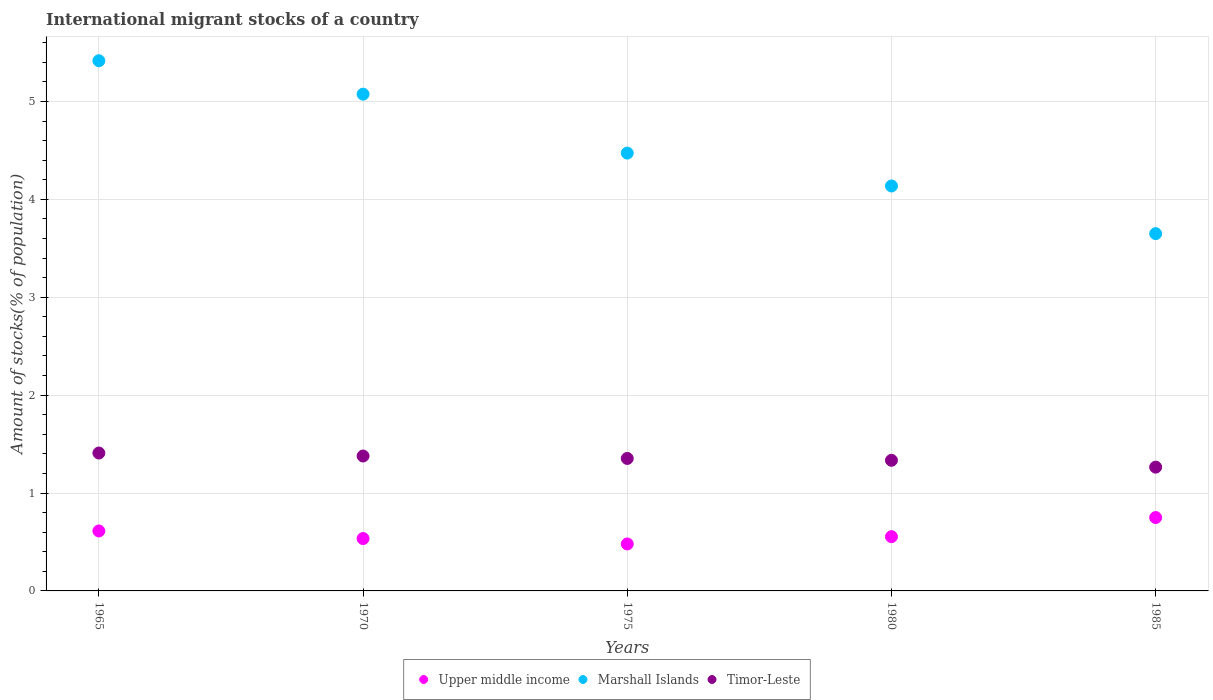What is the amount of stocks in in Upper middle income in 1985?
Your answer should be very brief. 0.75. Across all years, what is the maximum amount of stocks in in Timor-Leste?
Ensure brevity in your answer.  1.41. Across all years, what is the minimum amount of stocks in in Upper middle income?
Provide a succinct answer. 0.48. In which year was the amount of stocks in in Marshall Islands maximum?
Make the answer very short. 1965. In which year was the amount of stocks in in Upper middle income minimum?
Give a very brief answer. 1975. What is the total amount of stocks in in Upper middle income in the graph?
Provide a short and direct response. 2.93. What is the difference between the amount of stocks in in Upper middle income in 1965 and that in 1985?
Make the answer very short. -0.14. What is the difference between the amount of stocks in in Marshall Islands in 1985 and the amount of stocks in in Timor-Leste in 1975?
Offer a terse response. 2.3. What is the average amount of stocks in in Timor-Leste per year?
Ensure brevity in your answer.  1.35. In the year 1970, what is the difference between the amount of stocks in in Marshall Islands and amount of stocks in in Upper middle income?
Keep it short and to the point. 4.54. In how many years, is the amount of stocks in in Timor-Leste greater than 4 %?
Offer a terse response. 0. What is the ratio of the amount of stocks in in Timor-Leste in 1965 to that in 1980?
Your response must be concise. 1.06. Is the amount of stocks in in Marshall Islands in 1965 less than that in 1975?
Give a very brief answer. No. Is the difference between the amount of stocks in in Marshall Islands in 1970 and 1975 greater than the difference between the amount of stocks in in Upper middle income in 1970 and 1975?
Provide a succinct answer. Yes. What is the difference between the highest and the second highest amount of stocks in in Marshall Islands?
Offer a very short reply. 0.34. What is the difference between the highest and the lowest amount of stocks in in Upper middle income?
Your answer should be very brief. 0.27. Is the amount of stocks in in Upper middle income strictly greater than the amount of stocks in in Marshall Islands over the years?
Offer a very short reply. No. Is the amount of stocks in in Marshall Islands strictly less than the amount of stocks in in Timor-Leste over the years?
Offer a very short reply. No. How many years are there in the graph?
Offer a terse response. 5. Does the graph contain any zero values?
Give a very brief answer. No. Where does the legend appear in the graph?
Provide a succinct answer. Bottom center. How many legend labels are there?
Keep it short and to the point. 3. How are the legend labels stacked?
Make the answer very short. Horizontal. What is the title of the graph?
Keep it short and to the point. International migrant stocks of a country. What is the label or title of the Y-axis?
Make the answer very short. Amount of stocks(% of population). What is the Amount of stocks(% of population) in Upper middle income in 1965?
Ensure brevity in your answer.  0.61. What is the Amount of stocks(% of population) in Marshall Islands in 1965?
Your answer should be very brief. 5.42. What is the Amount of stocks(% of population) of Timor-Leste in 1965?
Offer a terse response. 1.41. What is the Amount of stocks(% of population) in Upper middle income in 1970?
Keep it short and to the point. 0.54. What is the Amount of stocks(% of population) of Marshall Islands in 1970?
Your answer should be compact. 5.07. What is the Amount of stocks(% of population) of Timor-Leste in 1970?
Ensure brevity in your answer.  1.38. What is the Amount of stocks(% of population) of Upper middle income in 1975?
Give a very brief answer. 0.48. What is the Amount of stocks(% of population) of Marshall Islands in 1975?
Ensure brevity in your answer.  4.47. What is the Amount of stocks(% of population) of Timor-Leste in 1975?
Provide a short and direct response. 1.35. What is the Amount of stocks(% of population) in Upper middle income in 1980?
Make the answer very short. 0.55. What is the Amount of stocks(% of population) of Marshall Islands in 1980?
Provide a short and direct response. 4.14. What is the Amount of stocks(% of population) of Timor-Leste in 1980?
Give a very brief answer. 1.33. What is the Amount of stocks(% of population) of Upper middle income in 1985?
Keep it short and to the point. 0.75. What is the Amount of stocks(% of population) of Marshall Islands in 1985?
Keep it short and to the point. 3.65. What is the Amount of stocks(% of population) of Timor-Leste in 1985?
Keep it short and to the point. 1.26. Across all years, what is the maximum Amount of stocks(% of population) in Upper middle income?
Provide a short and direct response. 0.75. Across all years, what is the maximum Amount of stocks(% of population) in Marshall Islands?
Provide a short and direct response. 5.42. Across all years, what is the maximum Amount of stocks(% of population) of Timor-Leste?
Your answer should be compact. 1.41. Across all years, what is the minimum Amount of stocks(% of population) in Upper middle income?
Offer a very short reply. 0.48. Across all years, what is the minimum Amount of stocks(% of population) in Marshall Islands?
Your answer should be very brief. 3.65. Across all years, what is the minimum Amount of stocks(% of population) of Timor-Leste?
Provide a succinct answer. 1.26. What is the total Amount of stocks(% of population) of Upper middle income in the graph?
Offer a terse response. 2.93. What is the total Amount of stocks(% of population) of Marshall Islands in the graph?
Ensure brevity in your answer.  22.75. What is the total Amount of stocks(% of population) in Timor-Leste in the graph?
Your answer should be compact. 6.74. What is the difference between the Amount of stocks(% of population) in Upper middle income in 1965 and that in 1970?
Give a very brief answer. 0.08. What is the difference between the Amount of stocks(% of population) in Marshall Islands in 1965 and that in 1970?
Ensure brevity in your answer.  0.34. What is the difference between the Amount of stocks(% of population) in Timor-Leste in 1965 and that in 1970?
Make the answer very short. 0.03. What is the difference between the Amount of stocks(% of population) of Upper middle income in 1965 and that in 1975?
Your answer should be compact. 0.13. What is the difference between the Amount of stocks(% of population) in Marshall Islands in 1965 and that in 1975?
Provide a succinct answer. 0.94. What is the difference between the Amount of stocks(% of population) in Timor-Leste in 1965 and that in 1975?
Provide a succinct answer. 0.06. What is the difference between the Amount of stocks(% of population) in Upper middle income in 1965 and that in 1980?
Your response must be concise. 0.06. What is the difference between the Amount of stocks(% of population) of Marshall Islands in 1965 and that in 1980?
Your answer should be compact. 1.28. What is the difference between the Amount of stocks(% of population) in Timor-Leste in 1965 and that in 1980?
Provide a short and direct response. 0.07. What is the difference between the Amount of stocks(% of population) of Upper middle income in 1965 and that in 1985?
Ensure brevity in your answer.  -0.14. What is the difference between the Amount of stocks(% of population) of Marshall Islands in 1965 and that in 1985?
Make the answer very short. 1.77. What is the difference between the Amount of stocks(% of population) in Timor-Leste in 1965 and that in 1985?
Ensure brevity in your answer.  0.14. What is the difference between the Amount of stocks(% of population) in Upper middle income in 1970 and that in 1975?
Give a very brief answer. 0.06. What is the difference between the Amount of stocks(% of population) of Marshall Islands in 1970 and that in 1975?
Your response must be concise. 0.6. What is the difference between the Amount of stocks(% of population) in Timor-Leste in 1970 and that in 1975?
Offer a very short reply. 0.02. What is the difference between the Amount of stocks(% of population) in Upper middle income in 1970 and that in 1980?
Provide a succinct answer. -0.02. What is the difference between the Amount of stocks(% of population) in Marshall Islands in 1970 and that in 1980?
Keep it short and to the point. 0.94. What is the difference between the Amount of stocks(% of population) of Timor-Leste in 1970 and that in 1980?
Your response must be concise. 0.04. What is the difference between the Amount of stocks(% of population) in Upper middle income in 1970 and that in 1985?
Make the answer very short. -0.21. What is the difference between the Amount of stocks(% of population) in Marshall Islands in 1970 and that in 1985?
Your answer should be very brief. 1.42. What is the difference between the Amount of stocks(% of population) in Timor-Leste in 1970 and that in 1985?
Provide a short and direct response. 0.11. What is the difference between the Amount of stocks(% of population) in Upper middle income in 1975 and that in 1980?
Give a very brief answer. -0.07. What is the difference between the Amount of stocks(% of population) of Marshall Islands in 1975 and that in 1980?
Make the answer very short. 0.34. What is the difference between the Amount of stocks(% of population) in Timor-Leste in 1975 and that in 1980?
Your answer should be compact. 0.02. What is the difference between the Amount of stocks(% of population) in Upper middle income in 1975 and that in 1985?
Provide a succinct answer. -0.27. What is the difference between the Amount of stocks(% of population) of Marshall Islands in 1975 and that in 1985?
Your answer should be compact. 0.82. What is the difference between the Amount of stocks(% of population) in Timor-Leste in 1975 and that in 1985?
Keep it short and to the point. 0.09. What is the difference between the Amount of stocks(% of population) of Upper middle income in 1980 and that in 1985?
Your response must be concise. -0.2. What is the difference between the Amount of stocks(% of population) in Marshall Islands in 1980 and that in 1985?
Give a very brief answer. 0.49. What is the difference between the Amount of stocks(% of population) of Timor-Leste in 1980 and that in 1985?
Ensure brevity in your answer.  0.07. What is the difference between the Amount of stocks(% of population) in Upper middle income in 1965 and the Amount of stocks(% of population) in Marshall Islands in 1970?
Provide a short and direct response. -4.46. What is the difference between the Amount of stocks(% of population) in Upper middle income in 1965 and the Amount of stocks(% of population) in Timor-Leste in 1970?
Make the answer very short. -0.77. What is the difference between the Amount of stocks(% of population) of Marshall Islands in 1965 and the Amount of stocks(% of population) of Timor-Leste in 1970?
Offer a terse response. 4.04. What is the difference between the Amount of stocks(% of population) in Upper middle income in 1965 and the Amount of stocks(% of population) in Marshall Islands in 1975?
Make the answer very short. -3.86. What is the difference between the Amount of stocks(% of population) in Upper middle income in 1965 and the Amount of stocks(% of population) in Timor-Leste in 1975?
Offer a terse response. -0.74. What is the difference between the Amount of stocks(% of population) in Marshall Islands in 1965 and the Amount of stocks(% of population) in Timor-Leste in 1975?
Offer a terse response. 4.06. What is the difference between the Amount of stocks(% of population) of Upper middle income in 1965 and the Amount of stocks(% of population) of Marshall Islands in 1980?
Ensure brevity in your answer.  -3.52. What is the difference between the Amount of stocks(% of population) in Upper middle income in 1965 and the Amount of stocks(% of population) in Timor-Leste in 1980?
Provide a succinct answer. -0.72. What is the difference between the Amount of stocks(% of population) of Marshall Islands in 1965 and the Amount of stocks(% of population) of Timor-Leste in 1980?
Your answer should be very brief. 4.08. What is the difference between the Amount of stocks(% of population) of Upper middle income in 1965 and the Amount of stocks(% of population) of Marshall Islands in 1985?
Your answer should be very brief. -3.04. What is the difference between the Amount of stocks(% of population) of Upper middle income in 1965 and the Amount of stocks(% of population) of Timor-Leste in 1985?
Provide a short and direct response. -0.65. What is the difference between the Amount of stocks(% of population) in Marshall Islands in 1965 and the Amount of stocks(% of population) in Timor-Leste in 1985?
Offer a terse response. 4.15. What is the difference between the Amount of stocks(% of population) of Upper middle income in 1970 and the Amount of stocks(% of population) of Marshall Islands in 1975?
Make the answer very short. -3.94. What is the difference between the Amount of stocks(% of population) in Upper middle income in 1970 and the Amount of stocks(% of population) in Timor-Leste in 1975?
Offer a terse response. -0.82. What is the difference between the Amount of stocks(% of population) of Marshall Islands in 1970 and the Amount of stocks(% of population) of Timor-Leste in 1975?
Offer a very short reply. 3.72. What is the difference between the Amount of stocks(% of population) of Upper middle income in 1970 and the Amount of stocks(% of population) of Marshall Islands in 1980?
Provide a succinct answer. -3.6. What is the difference between the Amount of stocks(% of population) of Upper middle income in 1970 and the Amount of stocks(% of population) of Timor-Leste in 1980?
Your answer should be compact. -0.8. What is the difference between the Amount of stocks(% of population) in Marshall Islands in 1970 and the Amount of stocks(% of population) in Timor-Leste in 1980?
Keep it short and to the point. 3.74. What is the difference between the Amount of stocks(% of population) in Upper middle income in 1970 and the Amount of stocks(% of population) in Marshall Islands in 1985?
Provide a short and direct response. -3.11. What is the difference between the Amount of stocks(% of population) in Upper middle income in 1970 and the Amount of stocks(% of population) in Timor-Leste in 1985?
Your answer should be compact. -0.73. What is the difference between the Amount of stocks(% of population) of Marshall Islands in 1970 and the Amount of stocks(% of population) of Timor-Leste in 1985?
Your answer should be compact. 3.81. What is the difference between the Amount of stocks(% of population) in Upper middle income in 1975 and the Amount of stocks(% of population) in Marshall Islands in 1980?
Provide a short and direct response. -3.66. What is the difference between the Amount of stocks(% of population) in Upper middle income in 1975 and the Amount of stocks(% of population) in Timor-Leste in 1980?
Make the answer very short. -0.85. What is the difference between the Amount of stocks(% of population) in Marshall Islands in 1975 and the Amount of stocks(% of population) in Timor-Leste in 1980?
Offer a terse response. 3.14. What is the difference between the Amount of stocks(% of population) of Upper middle income in 1975 and the Amount of stocks(% of population) of Marshall Islands in 1985?
Offer a terse response. -3.17. What is the difference between the Amount of stocks(% of population) of Upper middle income in 1975 and the Amount of stocks(% of population) of Timor-Leste in 1985?
Ensure brevity in your answer.  -0.78. What is the difference between the Amount of stocks(% of population) in Marshall Islands in 1975 and the Amount of stocks(% of population) in Timor-Leste in 1985?
Give a very brief answer. 3.21. What is the difference between the Amount of stocks(% of population) in Upper middle income in 1980 and the Amount of stocks(% of population) in Marshall Islands in 1985?
Give a very brief answer. -3.1. What is the difference between the Amount of stocks(% of population) in Upper middle income in 1980 and the Amount of stocks(% of population) in Timor-Leste in 1985?
Keep it short and to the point. -0.71. What is the difference between the Amount of stocks(% of population) in Marshall Islands in 1980 and the Amount of stocks(% of population) in Timor-Leste in 1985?
Give a very brief answer. 2.87. What is the average Amount of stocks(% of population) in Upper middle income per year?
Give a very brief answer. 0.59. What is the average Amount of stocks(% of population) in Marshall Islands per year?
Provide a short and direct response. 4.55. What is the average Amount of stocks(% of population) of Timor-Leste per year?
Your response must be concise. 1.35. In the year 1965, what is the difference between the Amount of stocks(% of population) of Upper middle income and Amount of stocks(% of population) of Marshall Islands?
Keep it short and to the point. -4.8. In the year 1965, what is the difference between the Amount of stocks(% of population) in Upper middle income and Amount of stocks(% of population) in Timor-Leste?
Give a very brief answer. -0.8. In the year 1965, what is the difference between the Amount of stocks(% of population) of Marshall Islands and Amount of stocks(% of population) of Timor-Leste?
Offer a very short reply. 4.01. In the year 1970, what is the difference between the Amount of stocks(% of population) of Upper middle income and Amount of stocks(% of population) of Marshall Islands?
Your response must be concise. -4.54. In the year 1970, what is the difference between the Amount of stocks(% of population) of Upper middle income and Amount of stocks(% of population) of Timor-Leste?
Your response must be concise. -0.84. In the year 1970, what is the difference between the Amount of stocks(% of population) of Marshall Islands and Amount of stocks(% of population) of Timor-Leste?
Give a very brief answer. 3.7. In the year 1975, what is the difference between the Amount of stocks(% of population) of Upper middle income and Amount of stocks(% of population) of Marshall Islands?
Your response must be concise. -3.99. In the year 1975, what is the difference between the Amount of stocks(% of population) in Upper middle income and Amount of stocks(% of population) in Timor-Leste?
Offer a terse response. -0.87. In the year 1975, what is the difference between the Amount of stocks(% of population) of Marshall Islands and Amount of stocks(% of population) of Timor-Leste?
Your answer should be compact. 3.12. In the year 1980, what is the difference between the Amount of stocks(% of population) of Upper middle income and Amount of stocks(% of population) of Marshall Islands?
Offer a terse response. -3.58. In the year 1980, what is the difference between the Amount of stocks(% of population) of Upper middle income and Amount of stocks(% of population) of Timor-Leste?
Ensure brevity in your answer.  -0.78. In the year 1980, what is the difference between the Amount of stocks(% of population) of Marshall Islands and Amount of stocks(% of population) of Timor-Leste?
Give a very brief answer. 2.8. In the year 1985, what is the difference between the Amount of stocks(% of population) in Upper middle income and Amount of stocks(% of population) in Marshall Islands?
Give a very brief answer. -2.9. In the year 1985, what is the difference between the Amount of stocks(% of population) of Upper middle income and Amount of stocks(% of population) of Timor-Leste?
Provide a succinct answer. -0.51. In the year 1985, what is the difference between the Amount of stocks(% of population) of Marshall Islands and Amount of stocks(% of population) of Timor-Leste?
Keep it short and to the point. 2.39. What is the ratio of the Amount of stocks(% of population) of Upper middle income in 1965 to that in 1970?
Provide a succinct answer. 1.14. What is the ratio of the Amount of stocks(% of population) in Marshall Islands in 1965 to that in 1970?
Provide a succinct answer. 1.07. What is the ratio of the Amount of stocks(% of population) in Timor-Leste in 1965 to that in 1970?
Keep it short and to the point. 1.02. What is the ratio of the Amount of stocks(% of population) in Upper middle income in 1965 to that in 1975?
Make the answer very short. 1.28. What is the ratio of the Amount of stocks(% of population) in Marshall Islands in 1965 to that in 1975?
Your answer should be very brief. 1.21. What is the ratio of the Amount of stocks(% of population) of Timor-Leste in 1965 to that in 1975?
Offer a terse response. 1.04. What is the ratio of the Amount of stocks(% of population) in Upper middle income in 1965 to that in 1980?
Keep it short and to the point. 1.11. What is the ratio of the Amount of stocks(% of population) in Marshall Islands in 1965 to that in 1980?
Give a very brief answer. 1.31. What is the ratio of the Amount of stocks(% of population) of Timor-Leste in 1965 to that in 1980?
Give a very brief answer. 1.06. What is the ratio of the Amount of stocks(% of population) of Upper middle income in 1965 to that in 1985?
Provide a succinct answer. 0.82. What is the ratio of the Amount of stocks(% of population) in Marshall Islands in 1965 to that in 1985?
Provide a succinct answer. 1.48. What is the ratio of the Amount of stocks(% of population) of Timor-Leste in 1965 to that in 1985?
Ensure brevity in your answer.  1.11. What is the ratio of the Amount of stocks(% of population) in Upper middle income in 1970 to that in 1975?
Give a very brief answer. 1.12. What is the ratio of the Amount of stocks(% of population) in Marshall Islands in 1970 to that in 1975?
Make the answer very short. 1.13. What is the ratio of the Amount of stocks(% of population) in Timor-Leste in 1970 to that in 1975?
Make the answer very short. 1.02. What is the ratio of the Amount of stocks(% of population) of Upper middle income in 1970 to that in 1980?
Your response must be concise. 0.97. What is the ratio of the Amount of stocks(% of population) in Marshall Islands in 1970 to that in 1980?
Offer a terse response. 1.23. What is the ratio of the Amount of stocks(% of population) of Timor-Leste in 1970 to that in 1980?
Your answer should be very brief. 1.03. What is the ratio of the Amount of stocks(% of population) of Upper middle income in 1970 to that in 1985?
Offer a very short reply. 0.71. What is the ratio of the Amount of stocks(% of population) in Marshall Islands in 1970 to that in 1985?
Offer a terse response. 1.39. What is the ratio of the Amount of stocks(% of population) in Timor-Leste in 1970 to that in 1985?
Your answer should be compact. 1.09. What is the ratio of the Amount of stocks(% of population) in Upper middle income in 1975 to that in 1980?
Provide a short and direct response. 0.87. What is the ratio of the Amount of stocks(% of population) of Marshall Islands in 1975 to that in 1980?
Your answer should be compact. 1.08. What is the ratio of the Amount of stocks(% of population) in Timor-Leste in 1975 to that in 1980?
Your answer should be very brief. 1.01. What is the ratio of the Amount of stocks(% of population) in Upper middle income in 1975 to that in 1985?
Your answer should be compact. 0.64. What is the ratio of the Amount of stocks(% of population) of Marshall Islands in 1975 to that in 1985?
Your answer should be compact. 1.23. What is the ratio of the Amount of stocks(% of population) of Timor-Leste in 1975 to that in 1985?
Make the answer very short. 1.07. What is the ratio of the Amount of stocks(% of population) in Upper middle income in 1980 to that in 1985?
Make the answer very short. 0.74. What is the ratio of the Amount of stocks(% of population) in Marshall Islands in 1980 to that in 1985?
Your answer should be compact. 1.13. What is the ratio of the Amount of stocks(% of population) in Timor-Leste in 1980 to that in 1985?
Your response must be concise. 1.06. What is the difference between the highest and the second highest Amount of stocks(% of population) of Upper middle income?
Your answer should be compact. 0.14. What is the difference between the highest and the second highest Amount of stocks(% of population) in Marshall Islands?
Keep it short and to the point. 0.34. What is the difference between the highest and the second highest Amount of stocks(% of population) of Timor-Leste?
Your answer should be compact. 0.03. What is the difference between the highest and the lowest Amount of stocks(% of population) in Upper middle income?
Give a very brief answer. 0.27. What is the difference between the highest and the lowest Amount of stocks(% of population) of Marshall Islands?
Offer a very short reply. 1.77. What is the difference between the highest and the lowest Amount of stocks(% of population) of Timor-Leste?
Make the answer very short. 0.14. 